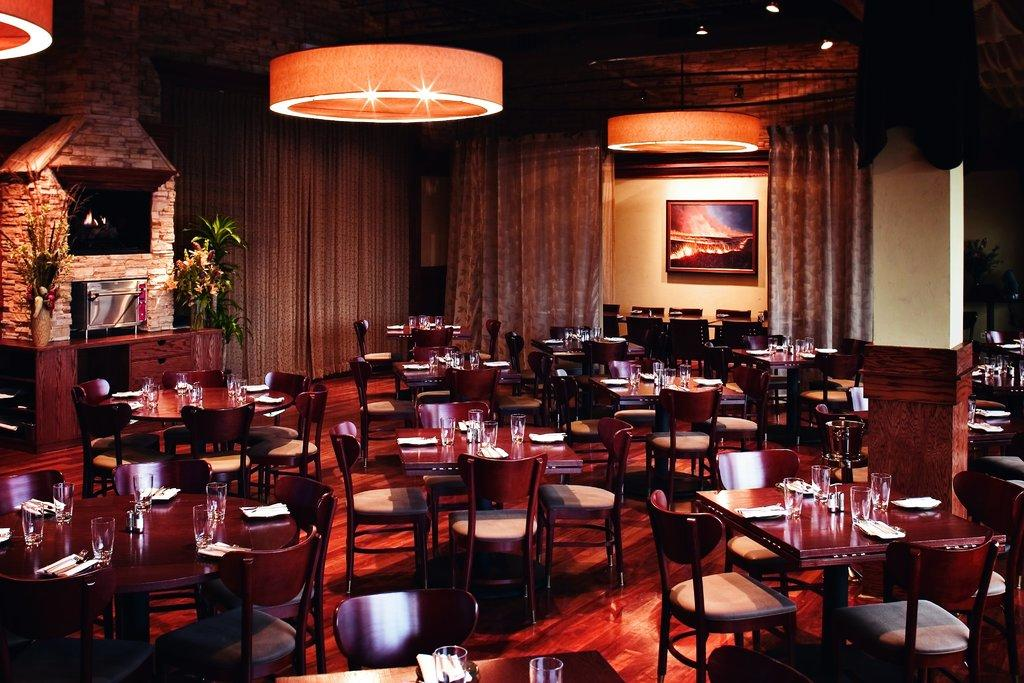What type of furniture is present in the image? There are tables and chairs in the image. What items might be used for drinking in the image? Glasses are visible in the image. What items might be used for eating in the image? Plates are present in the image. What items might be used for cleaning or wiping in the image? Tissues are in the image. What can be seen in the background of the image? There are curtains, cupboards, a photo frame, and a wall in the background of the image. How many bushes are visible in the image? There are no bushes present in the image. What type of animal is sitting on the chair in the image? There are no animals present in the image, including a donkey. 